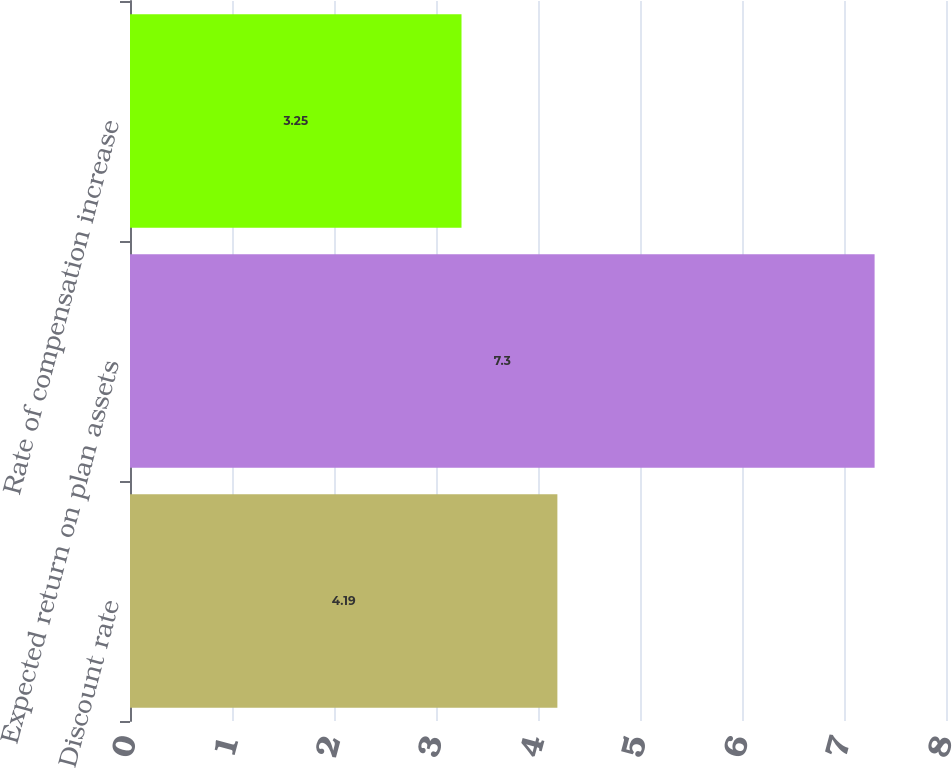<chart> <loc_0><loc_0><loc_500><loc_500><bar_chart><fcel>Discount rate<fcel>Expected return on plan assets<fcel>Rate of compensation increase<nl><fcel>4.19<fcel>7.3<fcel>3.25<nl></chart> 